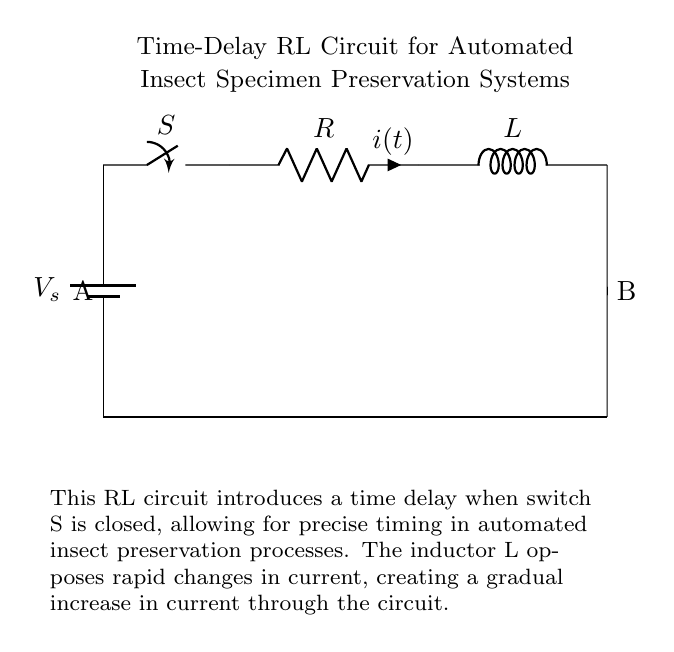What is the main function of the inductor in this circuit? The inductor L opposes rapid changes in current, resulting in a gradual increase in current through the circuit. This function is crucial in creating a time delay when switch S is closed, allowing for controlled timing in preservation processes.
Answer: Gradual current increase What is the presence of component S in the diagram? The switch S functions as a control element in the circuit. When closed, it completes the circuit, allowing current to flow from the voltage source through the resistor and inductor, initiating the time delay function.
Answer: Control element What happens to the current immediately after closing the switch? When the switch S is closed, the inductor L opposes the sudden change in current, leading to an initial current of zero and a gradual increase instead of an instantaneous jump. This characteristic behavior is fundamental to the delay the circuit provides.
Answer: Initially zero What type of circuit is represented by this diagram? This circuit is a Resistor-Inductor (RL) circuit, characterized by the inclusion of both a resistor and an inductor in connection with a power source, which provides specific behavior related to current changes and time delays in operation.
Answer: Resistor-Inductor What would you expect to see if the resistance \( R \) is increased? Increasing the resistance \( R \) results in a slower rate of change for the current in the circuit due to the increased opposition to current flow. This causes a longer time delay for the current to reach its maximum value after closing switch S.
Answer: Longer time delay 